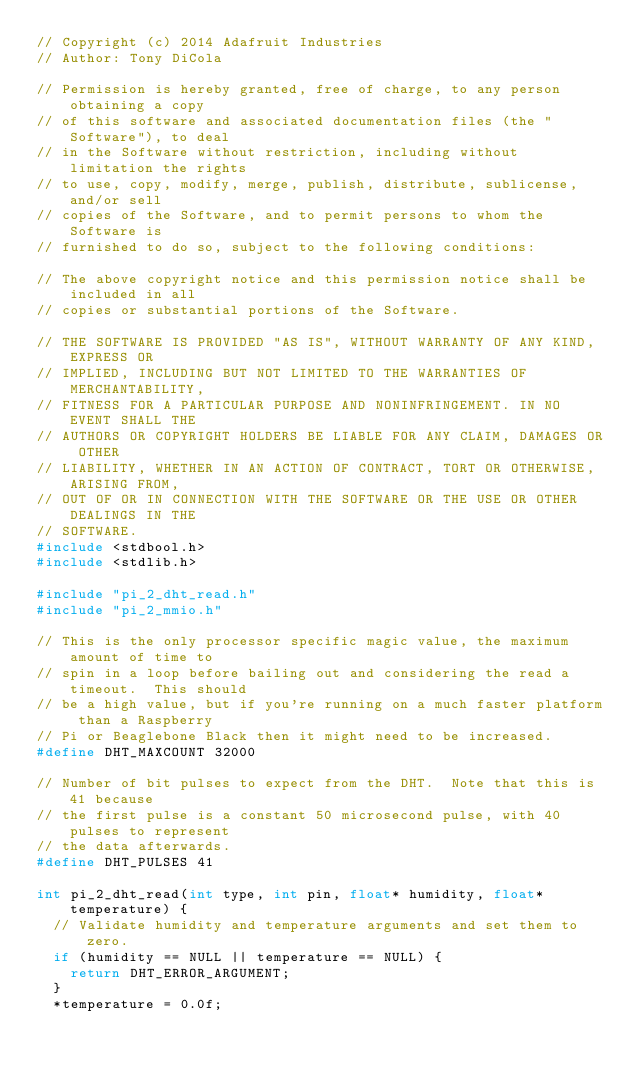Convert code to text. <code><loc_0><loc_0><loc_500><loc_500><_C_>// Copyright (c) 2014 Adafruit Industries
// Author: Tony DiCola

// Permission is hereby granted, free of charge, to any person obtaining a copy
// of this software and associated documentation files (the "Software"), to deal
// in the Software without restriction, including without limitation the rights
// to use, copy, modify, merge, publish, distribute, sublicense, and/or sell
// copies of the Software, and to permit persons to whom the Software is
// furnished to do so, subject to the following conditions:

// The above copyright notice and this permission notice shall be included in all
// copies or substantial portions of the Software.

// THE SOFTWARE IS PROVIDED "AS IS", WITHOUT WARRANTY OF ANY KIND, EXPRESS OR
// IMPLIED, INCLUDING BUT NOT LIMITED TO THE WARRANTIES OF MERCHANTABILITY,
// FITNESS FOR A PARTICULAR PURPOSE AND NONINFRINGEMENT. IN NO EVENT SHALL THE
// AUTHORS OR COPYRIGHT HOLDERS BE LIABLE FOR ANY CLAIM, DAMAGES OR OTHER
// LIABILITY, WHETHER IN AN ACTION OF CONTRACT, TORT OR OTHERWISE, ARISING FROM,
// OUT OF OR IN CONNECTION WITH THE SOFTWARE OR THE USE OR OTHER DEALINGS IN THE
// SOFTWARE.
#include <stdbool.h>
#include <stdlib.h>

#include "pi_2_dht_read.h"
#include "pi_2_mmio.h"

// This is the only processor specific magic value, the maximum amount of time to
// spin in a loop before bailing out and considering the read a timeout.  This should
// be a high value, but if you're running on a much faster platform than a Raspberry
// Pi or Beaglebone Black then it might need to be increased.
#define DHT_MAXCOUNT 32000

// Number of bit pulses to expect from the DHT.  Note that this is 41 because
// the first pulse is a constant 50 microsecond pulse, with 40 pulses to represent
// the data afterwards.
#define DHT_PULSES 41

int pi_2_dht_read(int type, int pin, float* humidity, float* temperature) {
  // Validate humidity and temperature arguments and set them to zero.
  if (humidity == NULL || temperature == NULL) {
    return DHT_ERROR_ARGUMENT;
  }
  *temperature = 0.0f;</code> 